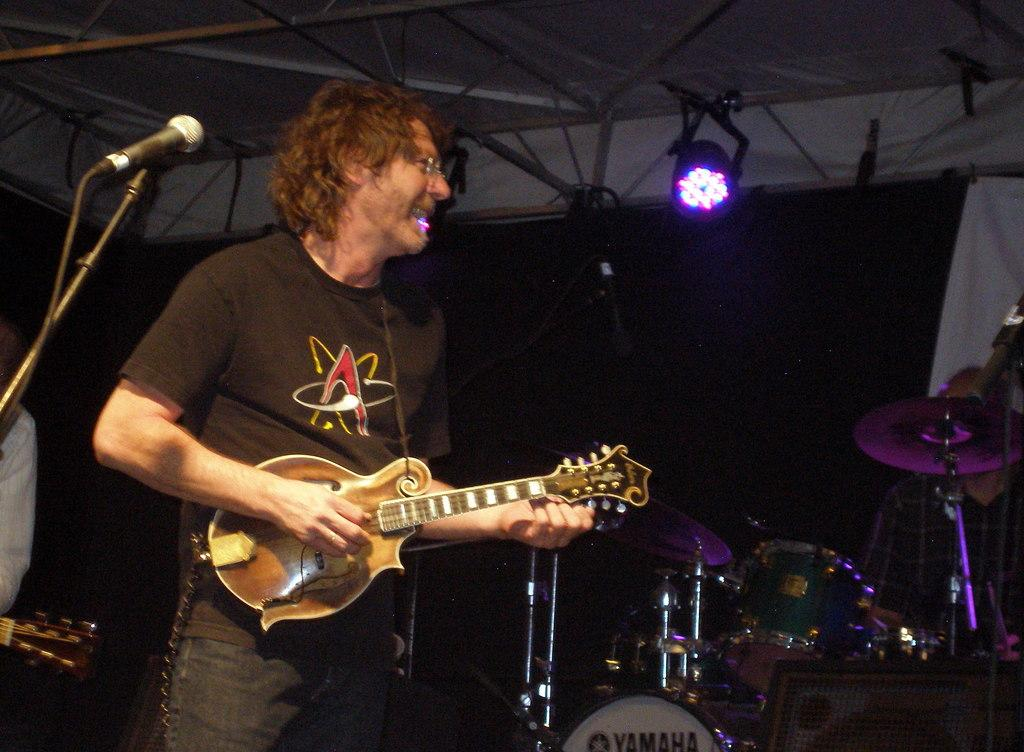What is the man on the left side of the image doing? The man is standing on the left side of the image and holding a guitar in his hand. What is the man's facial expression in the image? The man is smiling in the image. What other musical equipment can be seen in the image? There is a microphone and a snare drum in the image. What type of underwear is the man wearing in the image? There is no information about the man's underwear in the image, so it cannot be determined. 